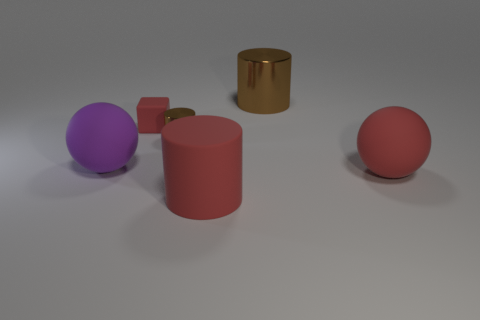Add 1 red rubber cubes. How many objects exist? 7 Subtract all cubes. How many objects are left? 5 Add 3 red matte balls. How many red matte balls are left? 4 Add 5 tiny green rubber spheres. How many tiny green rubber spheres exist? 5 Subtract 0 yellow cylinders. How many objects are left? 6 Subtract all large gray rubber spheres. Subtract all large balls. How many objects are left? 4 